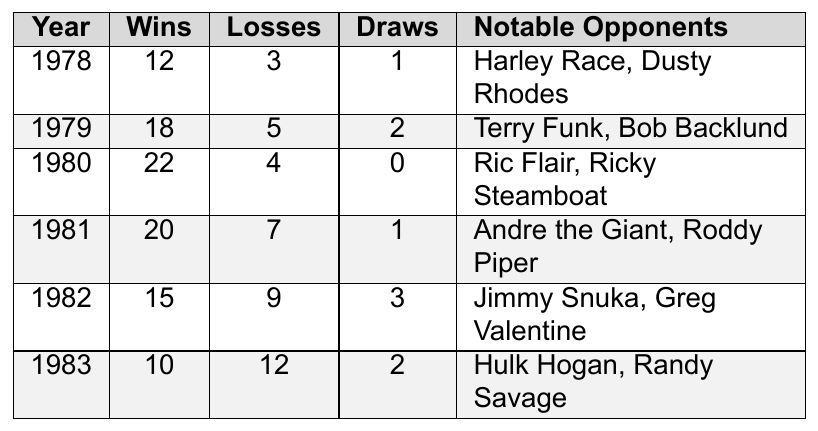What was Richard Thomas Bryant's total number of wins in 1980? According to the table, in 1980, Richard Thomas Bryant had 22 wins.
Answer: 22 How many draws did Richard Thomas Bryant have in 1982? In the table, it shows that Richard Thomas Bryant had 3 draws in 1982.
Answer: 3 What was the total number of losses across all years? To find the total losses, we add the losses from each year: (3 + 5 + 4 + 7 + 9 + 12) = 40.
Answer: 40 Which year had the highest number of wins? Reviewing the table, 1980 had the highest number of wins with 22.
Answer: 1980 Did Richard Thomas Bryant have more wins or losses in 1981? In 1981, he had 20 wins and 7 losses. Since 20 is greater than 7, he had more wins.
Answer: More wins What was the average number of wins from 1978 to 1983? To find the average, we sum the wins from each year (12 + 18 + 22 + 20 + 15 + 10 = 97) and divide by the number of years (6). Thus, the average is 97 / 6 = approximately 16.17.
Answer: Approximately 16.17 In which year did Richard Thomas Bryant face Hulk Hogan? According to the table, he faced Hulk Hogan in 1983.
Answer: 1983 What is the difference between the total wins in 1979 and the total wins in 1982? In 1979, he had 18 wins, and in 1982, he had 15 wins. The difference is 18 - 15 = 3.
Answer: 3 How many years did Richard Thomas Bryant have a winning record (more wins than losses)? In the table, he had a winning record in 1978, 1979, 1980, and 1981. This totals 4 years.
Answer: 4 Which notable opponent did Richard Thomas Bryant face in 1981? The table states that he faced Andre the Giant and Roddy Piper in 1981.
Answer: Andre the Giant and Roddy Piper What year had the largest number of losses? Reviewing the table, 1983 had the largest number of losses with 12.
Answer: 1983 